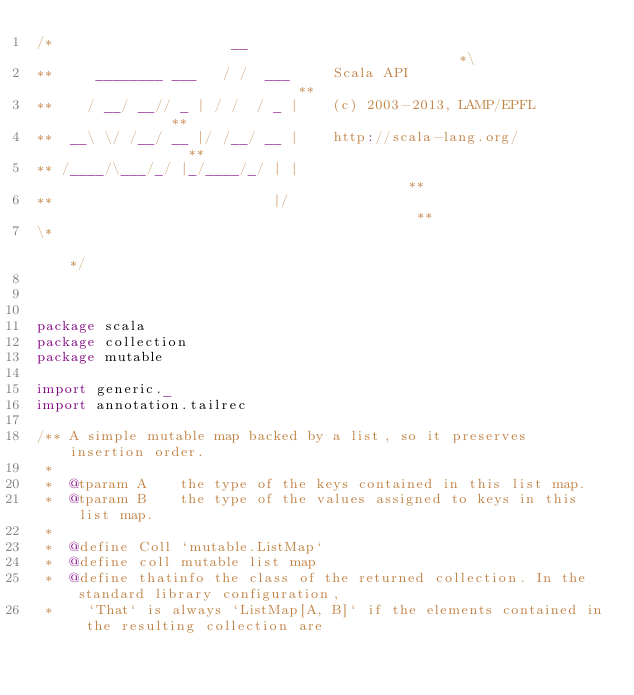Convert code to text. <code><loc_0><loc_0><loc_500><loc_500><_Scala_>/*                     __                                               *\
**     ________ ___   / /  ___     Scala API                            **
**    / __/ __// _ | / /  / _ |    (c) 2003-2013, LAMP/EPFL             **
**  __\ \/ /__/ __ |/ /__/ __ |    http://scala-lang.org/               **
** /____/\___/_/ |_/____/_/ | |                                         **
**                          |/                                          **
\*                                                                      */



package scala
package collection
package mutable

import generic._
import annotation.tailrec

/** A simple mutable map backed by a list, so it preserves insertion order.
 *
 *  @tparam A    the type of the keys contained in this list map.
 *  @tparam B    the type of the values assigned to keys in this list map.
 *
 *  @define Coll `mutable.ListMap`
 *  @define coll mutable list map
 *  @define thatinfo the class of the returned collection. In the standard library configuration,
 *    `That` is always `ListMap[A, B]` if the elements contained in the resulting collection are</code> 